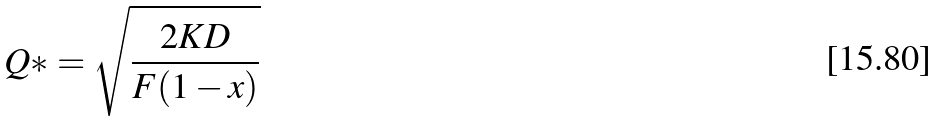Convert formula to latex. <formula><loc_0><loc_0><loc_500><loc_500>Q * = \sqrt { \frac { 2 K D } { F ( 1 - x ) } }</formula> 